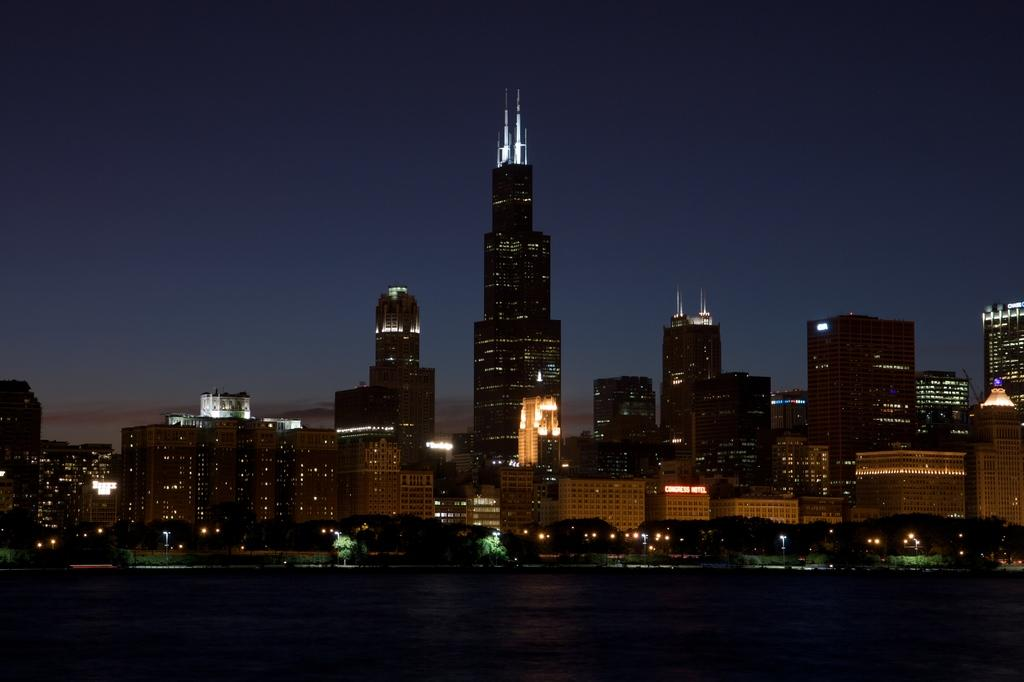What type of structures can be seen in the image? There are buildings in the image. What can be seen illuminating the scene in the image? There are lights in the image. What type of vegetation is present in the image? There are trees in the image. What are the vertical structures in the image used for? The poles in the image are likely used for supporting lights or other fixtures. What is visible at the top of the image? The sky is visible at the top of the image. What is visible at the bottom of the image? There is water visible at the bottom of the image. What type of trade is being conducted in the image? There is no indication of any trade being conducted in the image. Can you see the hand of the person who took the image? The image does not show the hand of the person who took the image, as it is a photograph and not a live scene. 